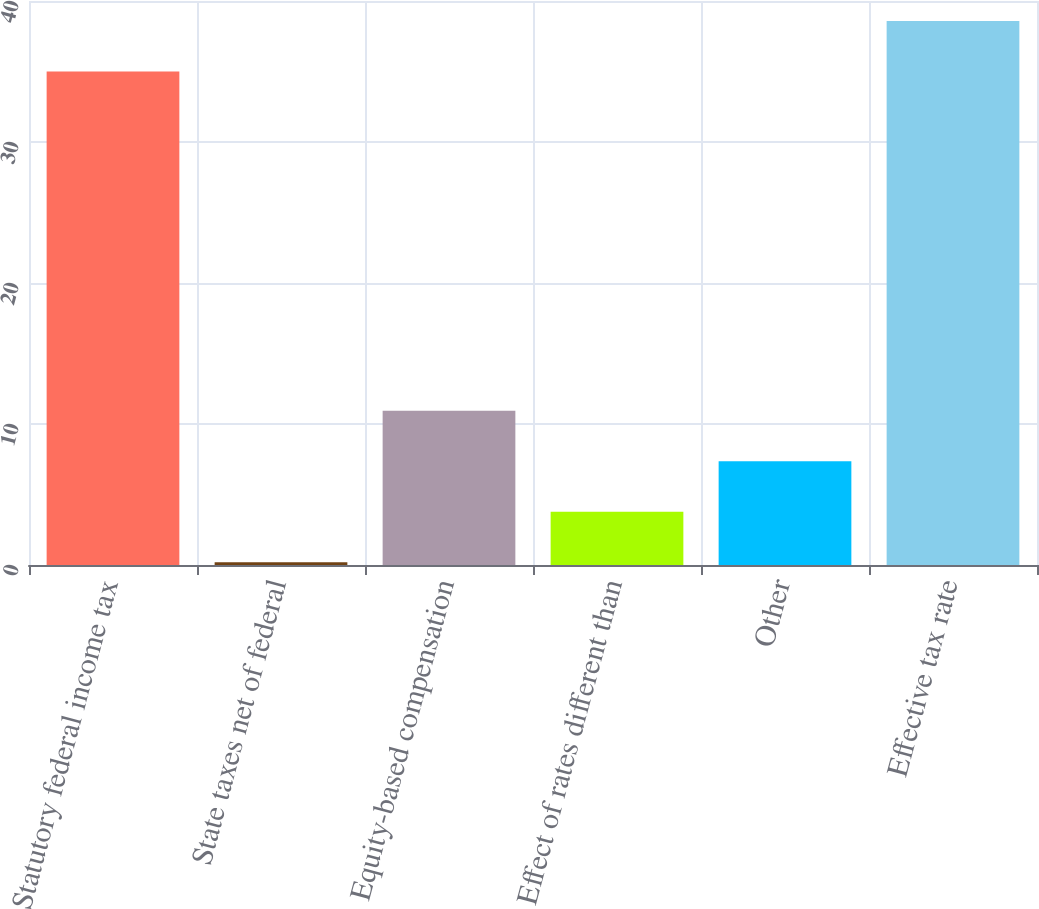Convert chart to OTSL. <chart><loc_0><loc_0><loc_500><loc_500><bar_chart><fcel>Statutory federal income tax<fcel>State taxes net of federal<fcel>Equity-based compensation<fcel>Effect of rates different than<fcel>Other<fcel>Effective tax rate<nl><fcel>35<fcel>0.2<fcel>10.94<fcel>3.78<fcel>7.36<fcel>38.58<nl></chart> 